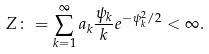Convert formula to latex. <formula><loc_0><loc_0><loc_500><loc_500>Z \colon = \sum _ { k = 1 } ^ { \infty } a _ { k } \frac { \psi _ { k } } { k } e ^ { - \psi _ { k } ^ { 2 } / 2 } < \infty .</formula> 